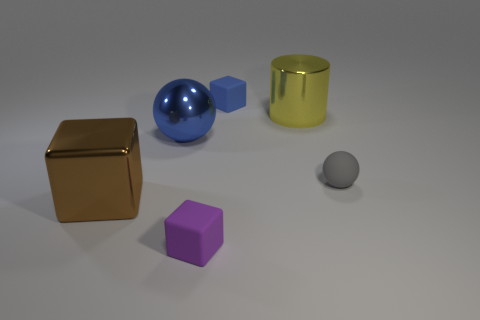Add 3 big blue objects. How many objects exist? 9 Subtract all cylinders. How many objects are left? 5 Add 6 purple metallic blocks. How many purple metallic blocks exist? 6 Subtract 0 green cylinders. How many objects are left? 6 Subtract all large green objects. Subtract all metallic cubes. How many objects are left? 5 Add 3 blue spheres. How many blue spheres are left? 4 